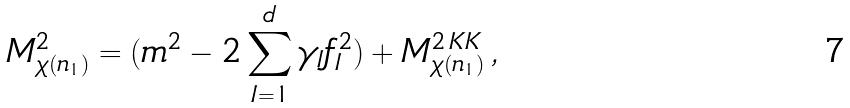<formula> <loc_0><loc_0><loc_500><loc_500>M ^ { 2 } _ { \chi ( n _ { 1 } ) } = ( m ^ { 2 } - 2 \sum _ { I = 1 } ^ { d } \gamma _ { I } f _ { I } ^ { 2 } ) + M ^ { 2 \, K K } _ { \chi ( n _ { 1 } ) } \, ,</formula> 